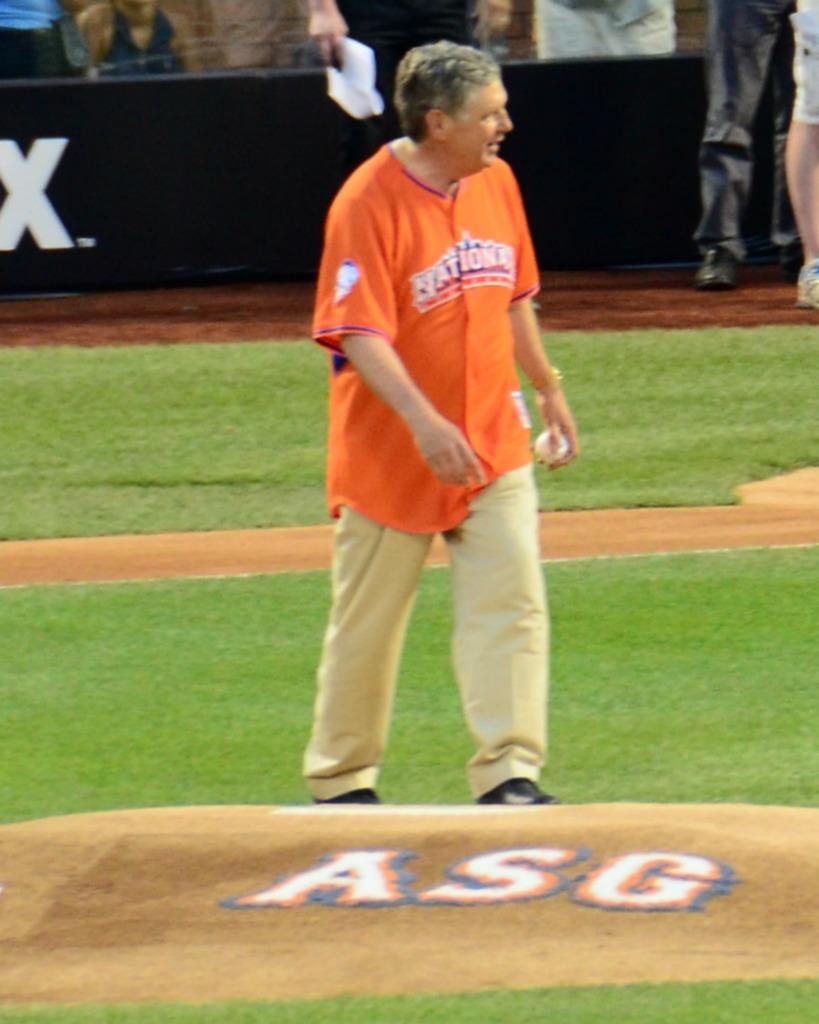What is the team name on the jersey?
Offer a terse response. Nationals. 